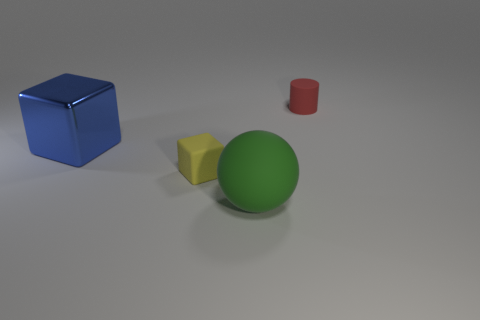Add 3 big green objects. How many objects exist? 7 Subtract all spheres. How many objects are left? 3 Add 3 blocks. How many blocks exist? 5 Subtract 0 brown cylinders. How many objects are left? 4 Subtract all big brown things. Subtract all red matte cylinders. How many objects are left? 3 Add 2 big green rubber balls. How many big green rubber balls are left? 3 